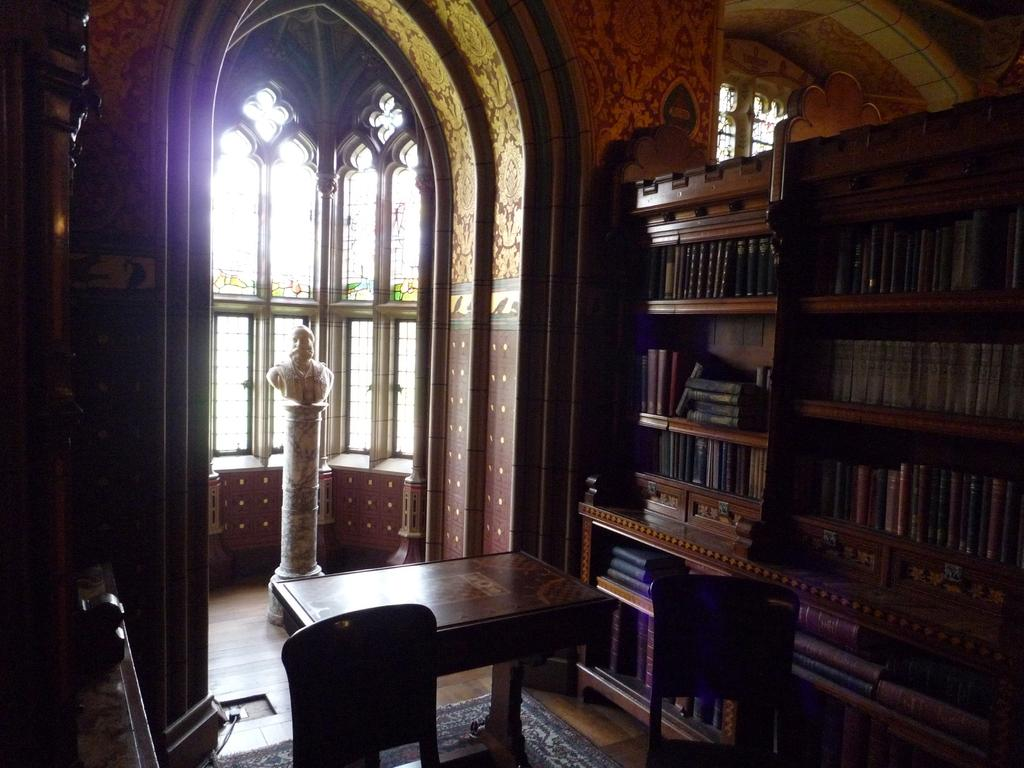What type of furniture is present in the image? There is a table and chairs in the image. What can be found inside the cupboard in the image? The cupboard contains books. What is located on top of the pillar in the image? There is a statue on a pillar in the image. What allows natural light to enter the room in the image? There are windows in the image. What type of silk material is draped over the floor in the image? There is no silk material present on the floor in the image. How many wheels can be seen on the statue in the image? The statue in the image does not have any wheels. 